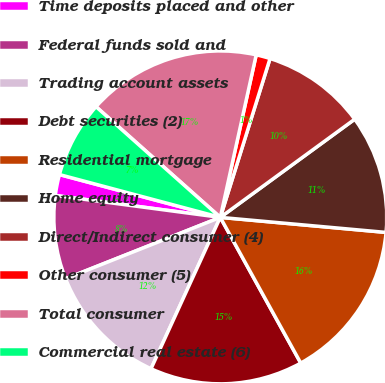Convert chart. <chart><loc_0><loc_0><loc_500><loc_500><pie_chart><fcel>Time deposits placed and other<fcel>Federal funds sold and<fcel>Trading account assets<fcel>Debt securities (2)<fcel>Residential mortgage<fcel>Home equity<fcel>Direct/Indirect consumer (4)<fcel>Other consumer (5)<fcel>Total consumer<fcel>Commercial real estate (6)<nl><fcel>2.04%<fcel>8.11%<fcel>12.16%<fcel>14.86%<fcel>15.53%<fcel>11.48%<fcel>10.13%<fcel>1.37%<fcel>16.88%<fcel>7.44%<nl></chart> 